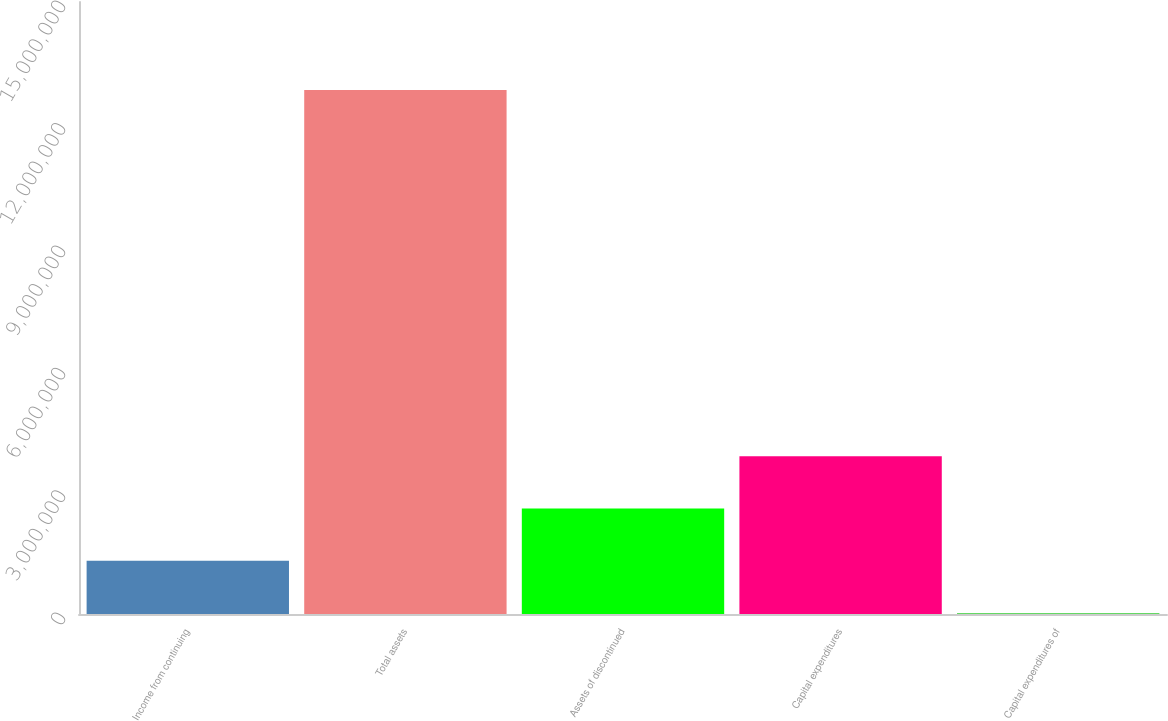Convert chart to OTSL. <chart><loc_0><loc_0><loc_500><loc_500><bar_chart><fcel>Income from continuing<fcel>Total assets<fcel>Assets of discontinued<fcel>Capital expenditures<fcel>Capital expenditures of<nl><fcel>1.30333e+06<fcel>1.28438e+07<fcel>2.58561e+06<fcel>3.86788e+06<fcel>21052<nl></chart> 